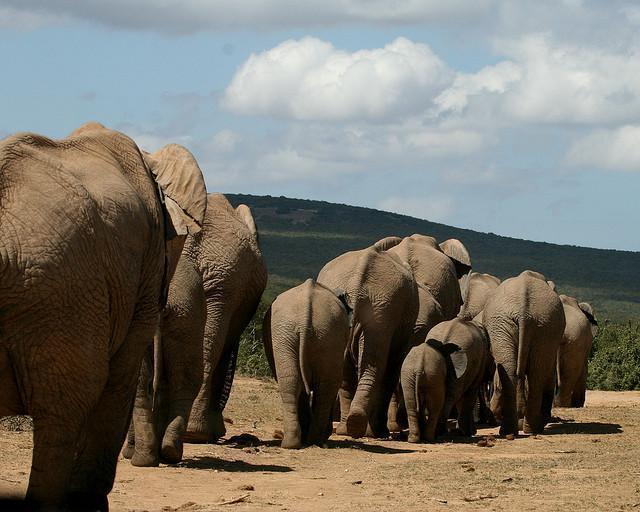How many elephants are there?
Give a very brief answer. 10. How many men are in this picture?
Give a very brief answer. 0. 